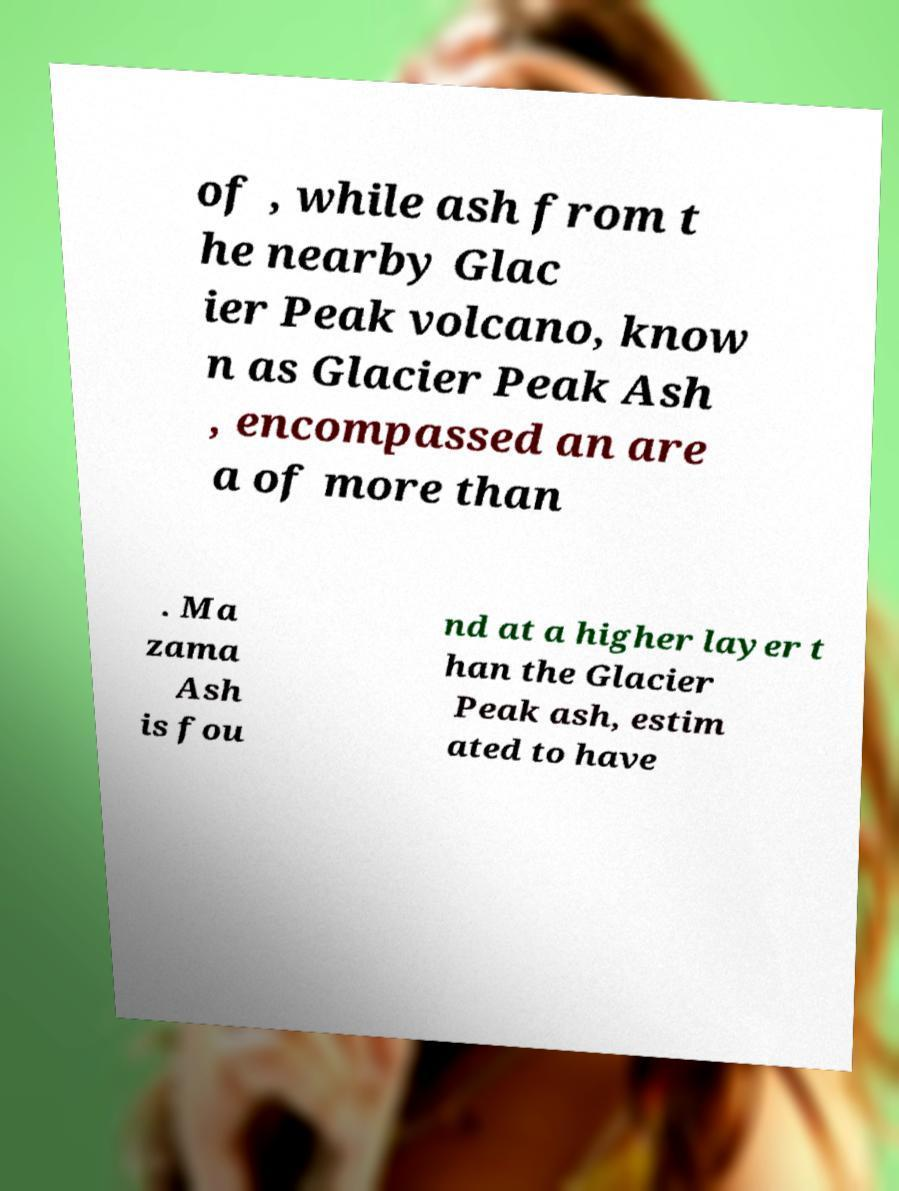What messages or text are displayed in this image? I need them in a readable, typed format. of , while ash from t he nearby Glac ier Peak volcano, know n as Glacier Peak Ash , encompassed an are a of more than . Ma zama Ash is fou nd at a higher layer t han the Glacier Peak ash, estim ated to have 